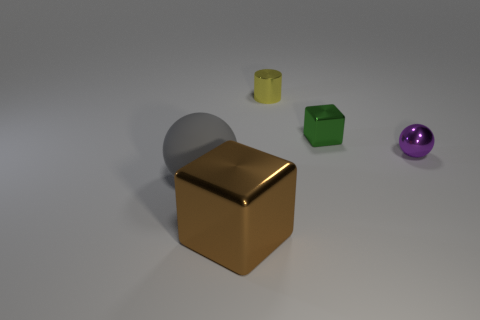Are there any other things that are the same material as the large sphere?
Provide a short and direct response. No. Are there more large gray matte balls right of the tiny purple shiny object than big metallic things that are behind the small cube?
Give a very brief answer. No. There is a small shiny object that is the same shape as the big metal thing; what color is it?
Make the answer very short. Green. Does the tiny object on the left side of the tiny green object have the same color as the rubber thing?
Your answer should be very brief. No. How many rubber objects are there?
Offer a very short reply. 1. Is the yellow object that is on the left side of the tiny green metallic block made of the same material as the tiny green cube?
Your answer should be very brief. Yes. There is a sphere right of the big object that is right of the big matte ball; what number of large rubber balls are on the right side of it?
Offer a terse response. 0. What is the size of the gray ball?
Offer a terse response. Large. Does the big rubber object have the same color as the tiny cylinder?
Provide a short and direct response. No. There is a metallic object that is behind the tiny metal cube; what is its size?
Offer a very short reply. Small. 